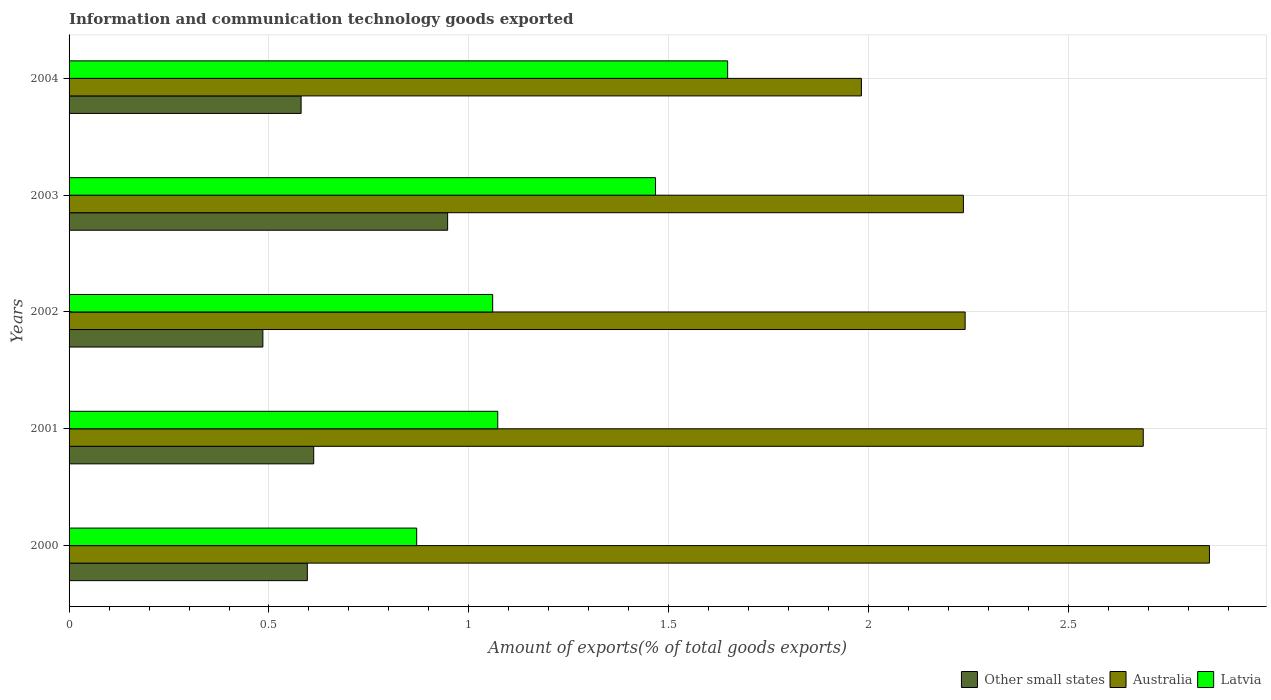How many different coloured bars are there?
Your answer should be compact. 3. Are the number of bars on each tick of the Y-axis equal?
Provide a short and direct response. Yes. How many bars are there on the 1st tick from the top?
Your answer should be very brief. 3. What is the amount of goods exported in Australia in 2004?
Make the answer very short. 1.98. Across all years, what is the maximum amount of goods exported in Other small states?
Give a very brief answer. 0.95. Across all years, what is the minimum amount of goods exported in Australia?
Provide a short and direct response. 1.98. In which year was the amount of goods exported in Other small states maximum?
Your answer should be compact. 2003. What is the total amount of goods exported in Other small states in the graph?
Give a very brief answer. 3.22. What is the difference between the amount of goods exported in Latvia in 2002 and that in 2003?
Offer a terse response. -0.41. What is the difference between the amount of goods exported in Other small states in 2000 and the amount of goods exported in Latvia in 2003?
Offer a very short reply. -0.87. What is the average amount of goods exported in Other small states per year?
Your answer should be compact. 0.64. In the year 2001, what is the difference between the amount of goods exported in Australia and amount of goods exported in Other small states?
Provide a succinct answer. 2.07. In how many years, is the amount of goods exported in Other small states greater than 1.5 %?
Your response must be concise. 0. What is the ratio of the amount of goods exported in Latvia in 2001 to that in 2003?
Offer a terse response. 0.73. Is the amount of goods exported in Other small states in 2000 less than that in 2001?
Offer a terse response. Yes. What is the difference between the highest and the second highest amount of goods exported in Other small states?
Provide a short and direct response. 0.33. What is the difference between the highest and the lowest amount of goods exported in Other small states?
Give a very brief answer. 0.46. In how many years, is the amount of goods exported in Australia greater than the average amount of goods exported in Australia taken over all years?
Your answer should be very brief. 2. What does the 1st bar from the top in 2003 represents?
Your answer should be very brief. Latvia. What does the 3rd bar from the bottom in 2003 represents?
Offer a terse response. Latvia. Are all the bars in the graph horizontal?
Ensure brevity in your answer.  Yes. Where does the legend appear in the graph?
Offer a very short reply. Bottom right. How many legend labels are there?
Offer a terse response. 3. What is the title of the graph?
Offer a very short reply. Information and communication technology goods exported. Does "Lesotho" appear as one of the legend labels in the graph?
Provide a succinct answer. No. What is the label or title of the X-axis?
Offer a terse response. Amount of exports(% of total goods exports). What is the label or title of the Y-axis?
Provide a short and direct response. Years. What is the Amount of exports(% of total goods exports) of Other small states in 2000?
Offer a terse response. 0.6. What is the Amount of exports(% of total goods exports) of Australia in 2000?
Your answer should be compact. 2.85. What is the Amount of exports(% of total goods exports) of Latvia in 2000?
Keep it short and to the point. 0.87. What is the Amount of exports(% of total goods exports) in Other small states in 2001?
Offer a very short reply. 0.61. What is the Amount of exports(% of total goods exports) in Australia in 2001?
Ensure brevity in your answer.  2.69. What is the Amount of exports(% of total goods exports) of Latvia in 2001?
Your answer should be very brief. 1.07. What is the Amount of exports(% of total goods exports) of Other small states in 2002?
Your response must be concise. 0.48. What is the Amount of exports(% of total goods exports) in Australia in 2002?
Provide a short and direct response. 2.24. What is the Amount of exports(% of total goods exports) of Latvia in 2002?
Make the answer very short. 1.06. What is the Amount of exports(% of total goods exports) in Other small states in 2003?
Your answer should be very brief. 0.95. What is the Amount of exports(% of total goods exports) of Australia in 2003?
Offer a very short reply. 2.24. What is the Amount of exports(% of total goods exports) of Latvia in 2003?
Offer a terse response. 1.47. What is the Amount of exports(% of total goods exports) of Other small states in 2004?
Ensure brevity in your answer.  0.58. What is the Amount of exports(% of total goods exports) of Australia in 2004?
Your answer should be very brief. 1.98. What is the Amount of exports(% of total goods exports) in Latvia in 2004?
Make the answer very short. 1.65. Across all years, what is the maximum Amount of exports(% of total goods exports) of Other small states?
Offer a terse response. 0.95. Across all years, what is the maximum Amount of exports(% of total goods exports) of Australia?
Give a very brief answer. 2.85. Across all years, what is the maximum Amount of exports(% of total goods exports) in Latvia?
Your answer should be very brief. 1.65. Across all years, what is the minimum Amount of exports(% of total goods exports) in Other small states?
Your answer should be compact. 0.48. Across all years, what is the minimum Amount of exports(% of total goods exports) of Australia?
Keep it short and to the point. 1.98. Across all years, what is the minimum Amount of exports(% of total goods exports) of Latvia?
Offer a very short reply. 0.87. What is the total Amount of exports(% of total goods exports) of Other small states in the graph?
Offer a terse response. 3.22. What is the total Amount of exports(% of total goods exports) of Australia in the graph?
Provide a short and direct response. 12. What is the total Amount of exports(% of total goods exports) of Latvia in the graph?
Keep it short and to the point. 6.11. What is the difference between the Amount of exports(% of total goods exports) in Other small states in 2000 and that in 2001?
Your answer should be compact. -0.02. What is the difference between the Amount of exports(% of total goods exports) of Australia in 2000 and that in 2001?
Keep it short and to the point. 0.17. What is the difference between the Amount of exports(% of total goods exports) of Latvia in 2000 and that in 2001?
Offer a very short reply. -0.2. What is the difference between the Amount of exports(% of total goods exports) in Other small states in 2000 and that in 2002?
Your answer should be very brief. 0.11. What is the difference between the Amount of exports(% of total goods exports) of Australia in 2000 and that in 2002?
Keep it short and to the point. 0.61. What is the difference between the Amount of exports(% of total goods exports) of Latvia in 2000 and that in 2002?
Make the answer very short. -0.19. What is the difference between the Amount of exports(% of total goods exports) of Other small states in 2000 and that in 2003?
Provide a succinct answer. -0.35. What is the difference between the Amount of exports(% of total goods exports) in Australia in 2000 and that in 2003?
Your answer should be compact. 0.62. What is the difference between the Amount of exports(% of total goods exports) in Latvia in 2000 and that in 2003?
Your answer should be compact. -0.6. What is the difference between the Amount of exports(% of total goods exports) of Other small states in 2000 and that in 2004?
Provide a short and direct response. 0.02. What is the difference between the Amount of exports(% of total goods exports) of Australia in 2000 and that in 2004?
Keep it short and to the point. 0.87. What is the difference between the Amount of exports(% of total goods exports) of Latvia in 2000 and that in 2004?
Provide a short and direct response. -0.78. What is the difference between the Amount of exports(% of total goods exports) of Other small states in 2001 and that in 2002?
Provide a short and direct response. 0.13. What is the difference between the Amount of exports(% of total goods exports) of Australia in 2001 and that in 2002?
Your response must be concise. 0.45. What is the difference between the Amount of exports(% of total goods exports) in Latvia in 2001 and that in 2002?
Your answer should be compact. 0.01. What is the difference between the Amount of exports(% of total goods exports) of Other small states in 2001 and that in 2003?
Make the answer very short. -0.33. What is the difference between the Amount of exports(% of total goods exports) in Australia in 2001 and that in 2003?
Offer a terse response. 0.45. What is the difference between the Amount of exports(% of total goods exports) in Latvia in 2001 and that in 2003?
Your response must be concise. -0.39. What is the difference between the Amount of exports(% of total goods exports) in Other small states in 2001 and that in 2004?
Offer a very short reply. 0.03. What is the difference between the Amount of exports(% of total goods exports) in Australia in 2001 and that in 2004?
Offer a very short reply. 0.7. What is the difference between the Amount of exports(% of total goods exports) in Latvia in 2001 and that in 2004?
Your answer should be very brief. -0.57. What is the difference between the Amount of exports(% of total goods exports) of Other small states in 2002 and that in 2003?
Your answer should be very brief. -0.46. What is the difference between the Amount of exports(% of total goods exports) of Australia in 2002 and that in 2003?
Make the answer very short. 0. What is the difference between the Amount of exports(% of total goods exports) of Latvia in 2002 and that in 2003?
Offer a very short reply. -0.41. What is the difference between the Amount of exports(% of total goods exports) of Other small states in 2002 and that in 2004?
Give a very brief answer. -0.1. What is the difference between the Amount of exports(% of total goods exports) in Australia in 2002 and that in 2004?
Offer a very short reply. 0.26. What is the difference between the Amount of exports(% of total goods exports) in Latvia in 2002 and that in 2004?
Provide a short and direct response. -0.59. What is the difference between the Amount of exports(% of total goods exports) of Other small states in 2003 and that in 2004?
Your response must be concise. 0.37. What is the difference between the Amount of exports(% of total goods exports) in Australia in 2003 and that in 2004?
Your answer should be compact. 0.26. What is the difference between the Amount of exports(% of total goods exports) of Latvia in 2003 and that in 2004?
Your answer should be compact. -0.18. What is the difference between the Amount of exports(% of total goods exports) in Other small states in 2000 and the Amount of exports(% of total goods exports) in Australia in 2001?
Ensure brevity in your answer.  -2.09. What is the difference between the Amount of exports(% of total goods exports) in Other small states in 2000 and the Amount of exports(% of total goods exports) in Latvia in 2001?
Your response must be concise. -0.48. What is the difference between the Amount of exports(% of total goods exports) of Australia in 2000 and the Amount of exports(% of total goods exports) of Latvia in 2001?
Ensure brevity in your answer.  1.78. What is the difference between the Amount of exports(% of total goods exports) of Other small states in 2000 and the Amount of exports(% of total goods exports) of Australia in 2002?
Your answer should be very brief. -1.65. What is the difference between the Amount of exports(% of total goods exports) in Other small states in 2000 and the Amount of exports(% of total goods exports) in Latvia in 2002?
Provide a short and direct response. -0.46. What is the difference between the Amount of exports(% of total goods exports) in Australia in 2000 and the Amount of exports(% of total goods exports) in Latvia in 2002?
Offer a very short reply. 1.79. What is the difference between the Amount of exports(% of total goods exports) of Other small states in 2000 and the Amount of exports(% of total goods exports) of Australia in 2003?
Provide a short and direct response. -1.64. What is the difference between the Amount of exports(% of total goods exports) in Other small states in 2000 and the Amount of exports(% of total goods exports) in Latvia in 2003?
Make the answer very short. -0.87. What is the difference between the Amount of exports(% of total goods exports) of Australia in 2000 and the Amount of exports(% of total goods exports) of Latvia in 2003?
Your answer should be compact. 1.39. What is the difference between the Amount of exports(% of total goods exports) of Other small states in 2000 and the Amount of exports(% of total goods exports) of Australia in 2004?
Ensure brevity in your answer.  -1.39. What is the difference between the Amount of exports(% of total goods exports) of Other small states in 2000 and the Amount of exports(% of total goods exports) of Latvia in 2004?
Your answer should be very brief. -1.05. What is the difference between the Amount of exports(% of total goods exports) in Australia in 2000 and the Amount of exports(% of total goods exports) in Latvia in 2004?
Offer a very short reply. 1.21. What is the difference between the Amount of exports(% of total goods exports) of Other small states in 2001 and the Amount of exports(% of total goods exports) of Australia in 2002?
Give a very brief answer. -1.63. What is the difference between the Amount of exports(% of total goods exports) in Other small states in 2001 and the Amount of exports(% of total goods exports) in Latvia in 2002?
Give a very brief answer. -0.45. What is the difference between the Amount of exports(% of total goods exports) of Australia in 2001 and the Amount of exports(% of total goods exports) of Latvia in 2002?
Provide a succinct answer. 1.63. What is the difference between the Amount of exports(% of total goods exports) in Other small states in 2001 and the Amount of exports(% of total goods exports) in Australia in 2003?
Offer a very short reply. -1.62. What is the difference between the Amount of exports(% of total goods exports) of Other small states in 2001 and the Amount of exports(% of total goods exports) of Latvia in 2003?
Provide a short and direct response. -0.85. What is the difference between the Amount of exports(% of total goods exports) of Australia in 2001 and the Amount of exports(% of total goods exports) of Latvia in 2003?
Provide a short and direct response. 1.22. What is the difference between the Amount of exports(% of total goods exports) in Other small states in 2001 and the Amount of exports(% of total goods exports) in Australia in 2004?
Offer a terse response. -1.37. What is the difference between the Amount of exports(% of total goods exports) in Other small states in 2001 and the Amount of exports(% of total goods exports) in Latvia in 2004?
Give a very brief answer. -1.04. What is the difference between the Amount of exports(% of total goods exports) in Australia in 2001 and the Amount of exports(% of total goods exports) in Latvia in 2004?
Your answer should be very brief. 1.04. What is the difference between the Amount of exports(% of total goods exports) in Other small states in 2002 and the Amount of exports(% of total goods exports) in Australia in 2003?
Provide a short and direct response. -1.75. What is the difference between the Amount of exports(% of total goods exports) in Other small states in 2002 and the Amount of exports(% of total goods exports) in Latvia in 2003?
Ensure brevity in your answer.  -0.98. What is the difference between the Amount of exports(% of total goods exports) in Australia in 2002 and the Amount of exports(% of total goods exports) in Latvia in 2003?
Provide a short and direct response. 0.77. What is the difference between the Amount of exports(% of total goods exports) in Other small states in 2002 and the Amount of exports(% of total goods exports) in Australia in 2004?
Give a very brief answer. -1.5. What is the difference between the Amount of exports(% of total goods exports) of Other small states in 2002 and the Amount of exports(% of total goods exports) of Latvia in 2004?
Provide a short and direct response. -1.16. What is the difference between the Amount of exports(% of total goods exports) of Australia in 2002 and the Amount of exports(% of total goods exports) of Latvia in 2004?
Keep it short and to the point. 0.59. What is the difference between the Amount of exports(% of total goods exports) in Other small states in 2003 and the Amount of exports(% of total goods exports) in Australia in 2004?
Your answer should be very brief. -1.03. What is the difference between the Amount of exports(% of total goods exports) of Other small states in 2003 and the Amount of exports(% of total goods exports) of Latvia in 2004?
Your response must be concise. -0.7. What is the difference between the Amount of exports(% of total goods exports) in Australia in 2003 and the Amount of exports(% of total goods exports) in Latvia in 2004?
Provide a short and direct response. 0.59. What is the average Amount of exports(% of total goods exports) in Other small states per year?
Give a very brief answer. 0.64. What is the average Amount of exports(% of total goods exports) of Australia per year?
Make the answer very short. 2.4. What is the average Amount of exports(% of total goods exports) of Latvia per year?
Provide a succinct answer. 1.22. In the year 2000, what is the difference between the Amount of exports(% of total goods exports) in Other small states and Amount of exports(% of total goods exports) in Australia?
Provide a short and direct response. -2.26. In the year 2000, what is the difference between the Amount of exports(% of total goods exports) in Other small states and Amount of exports(% of total goods exports) in Latvia?
Your answer should be very brief. -0.27. In the year 2000, what is the difference between the Amount of exports(% of total goods exports) of Australia and Amount of exports(% of total goods exports) of Latvia?
Give a very brief answer. 1.98. In the year 2001, what is the difference between the Amount of exports(% of total goods exports) of Other small states and Amount of exports(% of total goods exports) of Australia?
Give a very brief answer. -2.07. In the year 2001, what is the difference between the Amount of exports(% of total goods exports) of Other small states and Amount of exports(% of total goods exports) of Latvia?
Provide a short and direct response. -0.46. In the year 2001, what is the difference between the Amount of exports(% of total goods exports) in Australia and Amount of exports(% of total goods exports) in Latvia?
Your answer should be compact. 1.61. In the year 2002, what is the difference between the Amount of exports(% of total goods exports) of Other small states and Amount of exports(% of total goods exports) of Australia?
Your response must be concise. -1.76. In the year 2002, what is the difference between the Amount of exports(% of total goods exports) of Other small states and Amount of exports(% of total goods exports) of Latvia?
Offer a terse response. -0.57. In the year 2002, what is the difference between the Amount of exports(% of total goods exports) in Australia and Amount of exports(% of total goods exports) in Latvia?
Your answer should be compact. 1.18. In the year 2003, what is the difference between the Amount of exports(% of total goods exports) of Other small states and Amount of exports(% of total goods exports) of Australia?
Ensure brevity in your answer.  -1.29. In the year 2003, what is the difference between the Amount of exports(% of total goods exports) in Other small states and Amount of exports(% of total goods exports) in Latvia?
Provide a succinct answer. -0.52. In the year 2003, what is the difference between the Amount of exports(% of total goods exports) in Australia and Amount of exports(% of total goods exports) in Latvia?
Provide a short and direct response. 0.77. In the year 2004, what is the difference between the Amount of exports(% of total goods exports) in Other small states and Amount of exports(% of total goods exports) in Australia?
Provide a succinct answer. -1.4. In the year 2004, what is the difference between the Amount of exports(% of total goods exports) of Other small states and Amount of exports(% of total goods exports) of Latvia?
Keep it short and to the point. -1.07. In the year 2004, what is the difference between the Amount of exports(% of total goods exports) in Australia and Amount of exports(% of total goods exports) in Latvia?
Your answer should be compact. 0.33. What is the ratio of the Amount of exports(% of total goods exports) of Other small states in 2000 to that in 2001?
Provide a short and direct response. 0.97. What is the ratio of the Amount of exports(% of total goods exports) of Australia in 2000 to that in 2001?
Offer a very short reply. 1.06. What is the ratio of the Amount of exports(% of total goods exports) in Latvia in 2000 to that in 2001?
Your response must be concise. 0.81. What is the ratio of the Amount of exports(% of total goods exports) of Other small states in 2000 to that in 2002?
Your answer should be compact. 1.23. What is the ratio of the Amount of exports(% of total goods exports) in Australia in 2000 to that in 2002?
Give a very brief answer. 1.27. What is the ratio of the Amount of exports(% of total goods exports) in Latvia in 2000 to that in 2002?
Provide a succinct answer. 0.82. What is the ratio of the Amount of exports(% of total goods exports) in Other small states in 2000 to that in 2003?
Ensure brevity in your answer.  0.63. What is the ratio of the Amount of exports(% of total goods exports) in Australia in 2000 to that in 2003?
Offer a terse response. 1.28. What is the ratio of the Amount of exports(% of total goods exports) in Latvia in 2000 to that in 2003?
Offer a terse response. 0.59. What is the ratio of the Amount of exports(% of total goods exports) in Other small states in 2000 to that in 2004?
Ensure brevity in your answer.  1.03. What is the ratio of the Amount of exports(% of total goods exports) in Australia in 2000 to that in 2004?
Your response must be concise. 1.44. What is the ratio of the Amount of exports(% of total goods exports) of Latvia in 2000 to that in 2004?
Your answer should be compact. 0.53. What is the ratio of the Amount of exports(% of total goods exports) of Other small states in 2001 to that in 2002?
Offer a very short reply. 1.26. What is the ratio of the Amount of exports(% of total goods exports) of Australia in 2001 to that in 2002?
Offer a very short reply. 1.2. What is the ratio of the Amount of exports(% of total goods exports) in Latvia in 2001 to that in 2002?
Give a very brief answer. 1.01. What is the ratio of the Amount of exports(% of total goods exports) in Other small states in 2001 to that in 2003?
Offer a very short reply. 0.65. What is the ratio of the Amount of exports(% of total goods exports) of Australia in 2001 to that in 2003?
Keep it short and to the point. 1.2. What is the ratio of the Amount of exports(% of total goods exports) of Latvia in 2001 to that in 2003?
Your answer should be compact. 0.73. What is the ratio of the Amount of exports(% of total goods exports) in Other small states in 2001 to that in 2004?
Make the answer very short. 1.05. What is the ratio of the Amount of exports(% of total goods exports) in Australia in 2001 to that in 2004?
Your answer should be very brief. 1.36. What is the ratio of the Amount of exports(% of total goods exports) in Latvia in 2001 to that in 2004?
Provide a succinct answer. 0.65. What is the ratio of the Amount of exports(% of total goods exports) of Other small states in 2002 to that in 2003?
Give a very brief answer. 0.51. What is the ratio of the Amount of exports(% of total goods exports) in Latvia in 2002 to that in 2003?
Give a very brief answer. 0.72. What is the ratio of the Amount of exports(% of total goods exports) of Other small states in 2002 to that in 2004?
Ensure brevity in your answer.  0.84. What is the ratio of the Amount of exports(% of total goods exports) of Australia in 2002 to that in 2004?
Your answer should be very brief. 1.13. What is the ratio of the Amount of exports(% of total goods exports) of Latvia in 2002 to that in 2004?
Offer a very short reply. 0.64. What is the ratio of the Amount of exports(% of total goods exports) in Other small states in 2003 to that in 2004?
Provide a succinct answer. 1.63. What is the ratio of the Amount of exports(% of total goods exports) in Australia in 2003 to that in 2004?
Offer a terse response. 1.13. What is the ratio of the Amount of exports(% of total goods exports) of Latvia in 2003 to that in 2004?
Make the answer very short. 0.89. What is the difference between the highest and the second highest Amount of exports(% of total goods exports) in Other small states?
Keep it short and to the point. 0.33. What is the difference between the highest and the second highest Amount of exports(% of total goods exports) in Australia?
Offer a very short reply. 0.17. What is the difference between the highest and the second highest Amount of exports(% of total goods exports) of Latvia?
Give a very brief answer. 0.18. What is the difference between the highest and the lowest Amount of exports(% of total goods exports) of Other small states?
Your response must be concise. 0.46. What is the difference between the highest and the lowest Amount of exports(% of total goods exports) in Australia?
Ensure brevity in your answer.  0.87. What is the difference between the highest and the lowest Amount of exports(% of total goods exports) in Latvia?
Keep it short and to the point. 0.78. 